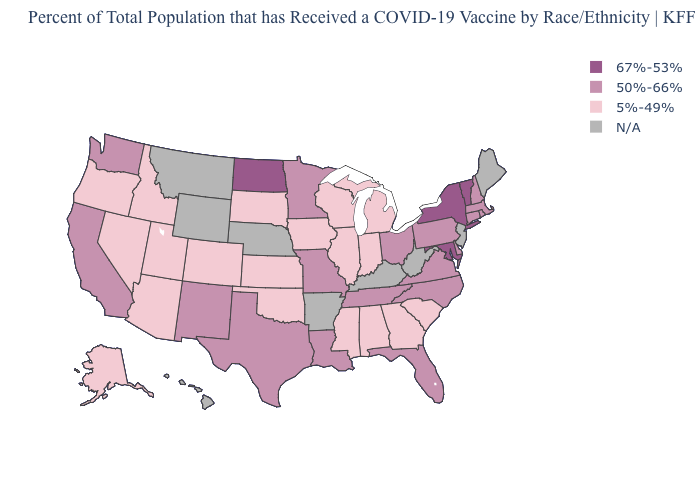Among the states that border Pennsylvania , does Delaware have the highest value?
Concise answer only. No. What is the lowest value in the USA?
Give a very brief answer. 5%-49%. What is the value of Michigan?
Short answer required. 5%-49%. What is the value of Colorado?
Give a very brief answer. 5%-49%. Does Virginia have the lowest value in the South?
Give a very brief answer. No. Name the states that have a value in the range 5%-49%?
Short answer required. Alabama, Alaska, Arizona, Colorado, Georgia, Idaho, Illinois, Indiana, Iowa, Kansas, Michigan, Mississippi, Nevada, Oklahoma, Oregon, South Carolina, South Dakota, Utah, Wisconsin. What is the value of Pennsylvania?
Keep it brief. 50%-66%. Among the states that border North Carolina , does Georgia have the highest value?
Be succinct. No. What is the lowest value in states that border New York?
Concise answer only. 50%-66%. Name the states that have a value in the range 67%-53%?
Keep it brief. Maryland, New York, North Dakota, Vermont. Name the states that have a value in the range 67%-53%?
Keep it brief. Maryland, New York, North Dakota, Vermont. Does the first symbol in the legend represent the smallest category?
Answer briefly. No. Name the states that have a value in the range 67%-53%?
Be succinct. Maryland, New York, North Dakota, Vermont. What is the highest value in the West ?
Be succinct. 50%-66%. 